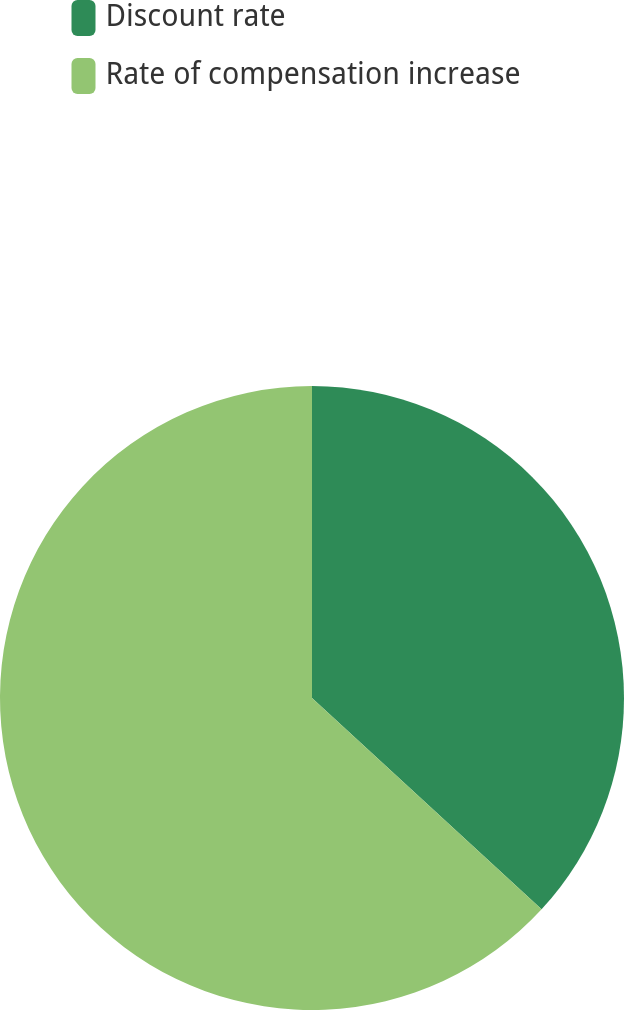Convert chart. <chart><loc_0><loc_0><loc_500><loc_500><pie_chart><fcel>Discount rate<fcel>Rate of compensation increase<nl><fcel>36.84%<fcel>63.16%<nl></chart> 